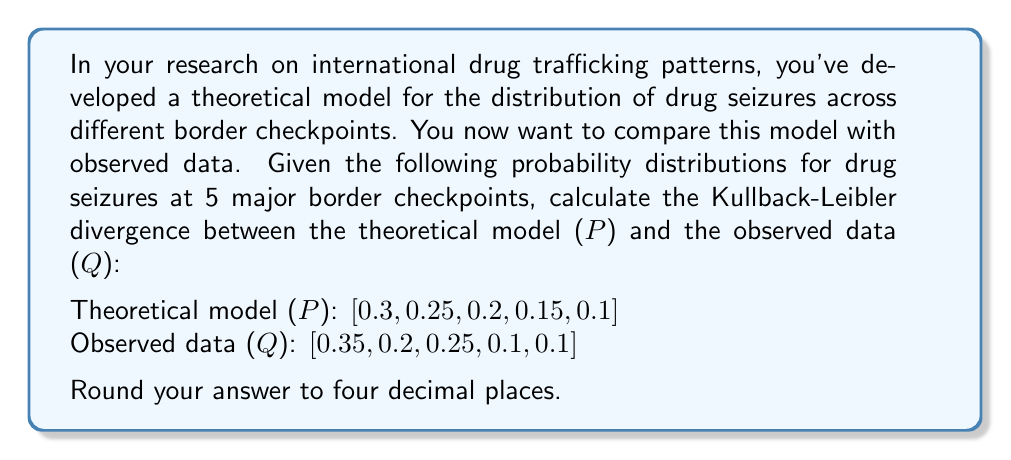Help me with this question. To calculate the Kullback-Leibler (KL) divergence between the theoretical model P and the observed data Q, we use the formula:

$$ D_{KL}(P||Q) = \sum_{i} P(i) \log \left(\frac{P(i)}{Q(i)}\right) $$

Where P(i) and Q(i) are the probabilities for each checkpoint in the theoretical and observed distributions, respectively.

Let's calculate this step-by-step:

1) For checkpoint 1:
   $P(1) = 0.3$, $Q(1) = 0.35$
   $0.3 \log(\frac{0.3}{0.35}) = 0.3 \log(0.8571) = -0.0460$

2) For checkpoint 2:
   $P(2) = 0.25$, $Q(2) = 0.2$
   $0.25 \log(\frac{0.25}{0.2}) = 0.25 \log(1.25) = 0.0558$

3) For checkpoint 3:
   $P(3) = 0.2$, $Q(3) = 0.25$
   $0.2 \log(\frac{0.2}{0.25}) = 0.2 \log(0.8) = -0.0458$

4) For checkpoint 4:
   $P(4) = 0.15$, $Q(4) = 0.1$
   $0.15 \log(\frac{0.15}{0.1}) = 0.15 \log(1.5) = 0.0608$

5) For checkpoint 5:
   $P(5) = 0.1$, $Q(5) = 0.1$
   $0.1 \log(\frac{0.1}{0.1}) = 0.1 \log(1) = 0$

Now, we sum all these values:

$$ D_{KL}(P||Q) = (-0.0460) + 0.0558 + (-0.0458) + 0.0608 + 0 = 0.0248 $$

Rounding to four decimal places gives us 0.0248.
Answer: 0.0248 